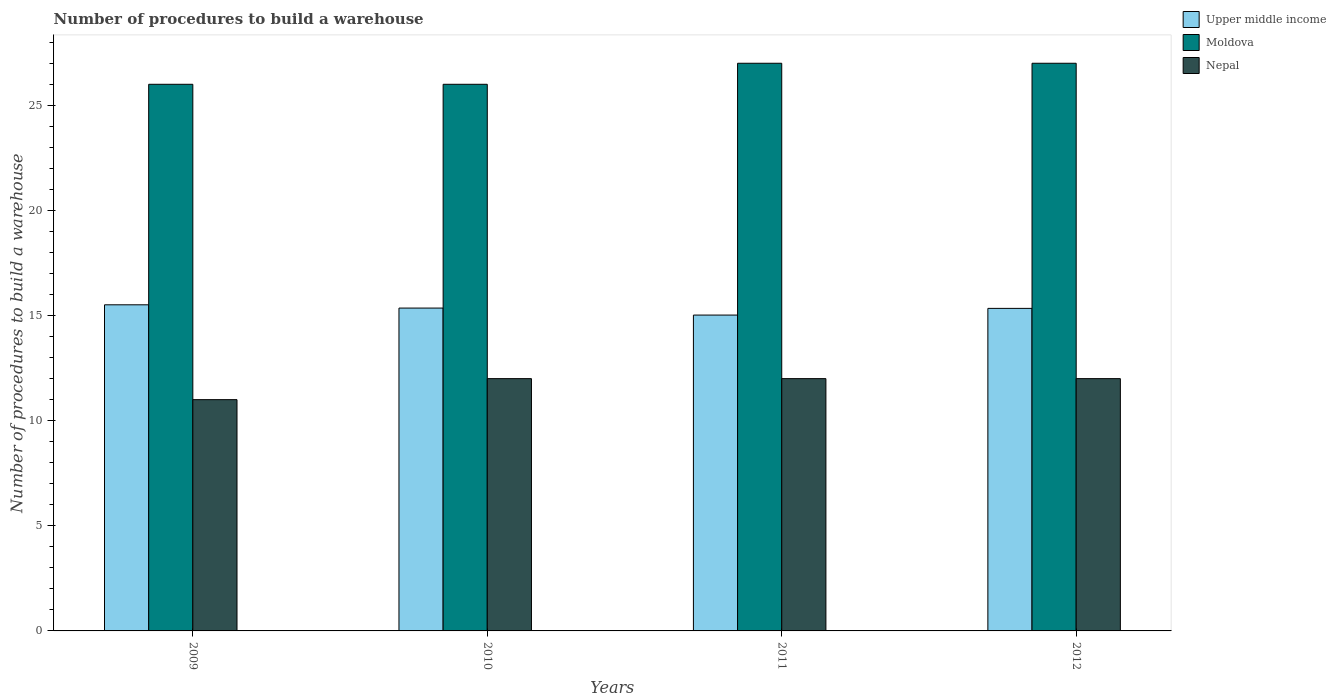How many groups of bars are there?
Your response must be concise. 4. Are the number of bars per tick equal to the number of legend labels?
Ensure brevity in your answer.  Yes. Are the number of bars on each tick of the X-axis equal?
Offer a terse response. Yes. What is the label of the 4th group of bars from the left?
Your answer should be compact. 2012. What is the number of procedures to build a warehouse in in Nepal in 2012?
Give a very brief answer. 12. Across all years, what is the maximum number of procedures to build a warehouse in in Moldova?
Your answer should be very brief. 27. Across all years, what is the minimum number of procedures to build a warehouse in in Moldova?
Keep it short and to the point. 26. In which year was the number of procedures to build a warehouse in in Upper middle income minimum?
Offer a terse response. 2011. What is the total number of procedures to build a warehouse in in Nepal in the graph?
Offer a terse response. 47. What is the difference between the number of procedures to build a warehouse in in Upper middle income in 2011 and that in 2012?
Give a very brief answer. -0.32. What is the difference between the number of procedures to build a warehouse in in Upper middle income in 2009 and the number of procedures to build a warehouse in in Moldova in 2012?
Offer a terse response. -11.49. What is the average number of procedures to build a warehouse in in Moldova per year?
Your answer should be compact. 26.5. In the year 2011, what is the difference between the number of procedures to build a warehouse in in Upper middle income and number of procedures to build a warehouse in in Moldova?
Make the answer very short. -11.98. What is the ratio of the number of procedures to build a warehouse in in Upper middle income in 2009 to that in 2011?
Your answer should be very brief. 1.03. Is the difference between the number of procedures to build a warehouse in in Upper middle income in 2009 and 2010 greater than the difference between the number of procedures to build a warehouse in in Moldova in 2009 and 2010?
Keep it short and to the point. Yes. What is the difference between the highest and the second highest number of procedures to build a warehouse in in Nepal?
Your answer should be very brief. 0. What is the difference between the highest and the lowest number of procedures to build a warehouse in in Nepal?
Your answer should be very brief. 1. In how many years, is the number of procedures to build a warehouse in in Moldova greater than the average number of procedures to build a warehouse in in Moldova taken over all years?
Ensure brevity in your answer.  2. What does the 2nd bar from the left in 2012 represents?
Your response must be concise. Moldova. What does the 1st bar from the right in 2012 represents?
Offer a terse response. Nepal. Are all the bars in the graph horizontal?
Offer a very short reply. No. How many years are there in the graph?
Your answer should be compact. 4. What is the difference between two consecutive major ticks on the Y-axis?
Offer a terse response. 5. How many legend labels are there?
Offer a terse response. 3. How are the legend labels stacked?
Provide a short and direct response. Vertical. What is the title of the graph?
Keep it short and to the point. Number of procedures to build a warehouse. Does "Monaco" appear as one of the legend labels in the graph?
Your answer should be compact. No. What is the label or title of the X-axis?
Offer a very short reply. Years. What is the label or title of the Y-axis?
Offer a very short reply. Number of procedures to build a warehouse. What is the Number of procedures to build a warehouse in Upper middle income in 2009?
Ensure brevity in your answer.  15.51. What is the Number of procedures to build a warehouse in Upper middle income in 2010?
Give a very brief answer. 15.36. What is the Number of procedures to build a warehouse of Moldova in 2010?
Your answer should be compact. 26. What is the Number of procedures to build a warehouse in Nepal in 2010?
Provide a succinct answer. 12. What is the Number of procedures to build a warehouse of Upper middle income in 2011?
Your response must be concise. 15.02. What is the Number of procedures to build a warehouse in Moldova in 2011?
Provide a succinct answer. 27. What is the Number of procedures to build a warehouse in Upper middle income in 2012?
Provide a succinct answer. 15.34. Across all years, what is the maximum Number of procedures to build a warehouse of Upper middle income?
Ensure brevity in your answer.  15.51. Across all years, what is the maximum Number of procedures to build a warehouse of Nepal?
Your answer should be compact. 12. Across all years, what is the minimum Number of procedures to build a warehouse in Upper middle income?
Make the answer very short. 15.02. Across all years, what is the minimum Number of procedures to build a warehouse in Nepal?
Provide a succinct answer. 11. What is the total Number of procedures to build a warehouse of Upper middle income in the graph?
Make the answer very short. 61.23. What is the total Number of procedures to build a warehouse in Moldova in the graph?
Keep it short and to the point. 106. What is the difference between the Number of procedures to build a warehouse of Upper middle income in 2009 and that in 2010?
Offer a very short reply. 0.16. What is the difference between the Number of procedures to build a warehouse in Upper middle income in 2009 and that in 2011?
Your answer should be compact. 0.49. What is the difference between the Number of procedures to build a warehouse of Upper middle income in 2009 and that in 2012?
Your response must be concise. 0.17. What is the difference between the Number of procedures to build a warehouse in Moldova in 2009 and that in 2012?
Your answer should be compact. -1. What is the difference between the Number of procedures to build a warehouse in Upper middle income in 2010 and that in 2011?
Give a very brief answer. 0.33. What is the difference between the Number of procedures to build a warehouse of Nepal in 2010 and that in 2011?
Your answer should be compact. 0. What is the difference between the Number of procedures to build a warehouse of Upper middle income in 2010 and that in 2012?
Give a very brief answer. 0.01. What is the difference between the Number of procedures to build a warehouse of Upper middle income in 2011 and that in 2012?
Offer a very short reply. -0.32. What is the difference between the Number of procedures to build a warehouse in Moldova in 2011 and that in 2012?
Your answer should be very brief. 0. What is the difference between the Number of procedures to build a warehouse in Upper middle income in 2009 and the Number of procedures to build a warehouse in Moldova in 2010?
Provide a succinct answer. -10.49. What is the difference between the Number of procedures to build a warehouse of Upper middle income in 2009 and the Number of procedures to build a warehouse of Nepal in 2010?
Ensure brevity in your answer.  3.51. What is the difference between the Number of procedures to build a warehouse in Upper middle income in 2009 and the Number of procedures to build a warehouse in Moldova in 2011?
Your answer should be very brief. -11.49. What is the difference between the Number of procedures to build a warehouse in Upper middle income in 2009 and the Number of procedures to build a warehouse in Nepal in 2011?
Provide a short and direct response. 3.51. What is the difference between the Number of procedures to build a warehouse in Upper middle income in 2009 and the Number of procedures to build a warehouse in Moldova in 2012?
Provide a short and direct response. -11.49. What is the difference between the Number of procedures to build a warehouse of Upper middle income in 2009 and the Number of procedures to build a warehouse of Nepal in 2012?
Your answer should be compact. 3.51. What is the difference between the Number of procedures to build a warehouse of Upper middle income in 2010 and the Number of procedures to build a warehouse of Moldova in 2011?
Provide a succinct answer. -11.64. What is the difference between the Number of procedures to build a warehouse of Upper middle income in 2010 and the Number of procedures to build a warehouse of Nepal in 2011?
Offer a terse response. 3.36. What is the difference between the Number of procedures to build a warehouse in Moldova in 2010 and the Number of procedures to build a warehouse in Nepal in 2011?
Give a very brief answer. 14. What is the difference between the Number of procedures to build a warehouse in Upper middle income in 2010 and the Number of procedures to build a warehouse in Moldova in 2012?
Offer a terse response. -11.64. What is the difference between the Number of procedures to build a warehouse in Upper middle income in 2010 and the Number of procedures to build a warehouse in Nepal in 2012?
Offer a terse response. 3.36. What is the difference between the Number of procedures to build a warehouse in Moldova in 2010 and the Number of procedures to build a warehouse in Nepal in 2012?
Make the answer very short. 14. What is the difference between the Number of procedures to build a warehouse of Upper middle income in 2011 and the Number of procedures to build a warehouse of Moldova in 2012?
Make the answer very short. -11.98. What is the difference between the Number of procedures to build a warehouse in Upper middle income in 2011 and the Number of procedures to build a warehouse in Nepal in 2012?
Ensure brevity in your answer.  3.02. What is the difference between the Number of procedures to build a warehouse in Moldova in 2011 and the Number of procedures to build a warehouse in Nepal in 2012?
Offer a very short reply. 15. What is the average Number of procedures to build a warehouse in Upper middle income per year?
Give a very brief answer. 15.31. What is the average Number of procedures to build a warehouse in Nepal per year?
Your response must be concise. 11.75. In the year 2009, what is the difference between the Number of procedures to build a warehouse in Upper middle income and Number of procedures to build a warehouse in Moldova?
Offer a terse response. -10.49. In the year 2009, what is the difference between the Number of procedures to build a warehouse of Upper middle income and Number of procedures to build a warehouse of Nepal?
Your response must be concise. 4.51. In the year 2009, what is the difference between the Number of procedures to build a warehouse of Moldova and Number of procedures to build a warehouse of Nepal?
Offer a very short reply. 15. In the year 2010, what is the difference between the Number of procedures to build a warehouse in Upper middle income and Number of procedures to build a warehouse in Moldova?
Offer a terse response. -10.64. In the year 2010, what is the difference between the Number of procedures to build a warehouse of Upper middle income and Number of procedures to build a warehouse of Nepal?
Ensure brevity in your answer.  3.36. In the year 2011, what is the difference between the Number of procedures to build a warehouse in Upper middle income and Number of procedures to build a warehouse in Moldova?
Provide a short and direct response. -11.98. In the year 2011, what is the difference between the Number of procedures to build a warehouse in Upper middle income and Number of procedures to build a warehouse in Nepal?
Provide a succinct answer. 3.02. In the year 2011, what is the difference between the Number of procedures to build a warehouse in Moldova and Number of procedures to build a warehouse in Nepal?
Provide a succinct answer. 15. In the year 2012, what is the difference between the Number of procedures to build a warehouse of Upper middle income and Number of procedures to build a warehouse of Moldova?
Ensure brevity in your answer.  -11.66. In the year 2012, what is the difference between the Number of procedures to build a warehouse of Upper middle income and Number of procedures to build a warehouse of Nepal?
Offer a very short reply. 3.34. In the year 2012, what is the difference between the Number of procedures to build a warehouse of Moldova and Number of procedures to build a warehouse of Nepal?
Provide a short and direct response. 15. What is the ratio of the Number of procedures to build a warehouse of Upper middle income in 2009 to that in 2011?
Your response must be concise. 1.03. What is the ratio of the Number of procedures to build a warehouse in Moldova in 2009 to that in 2011?
Provide a succinct answer. 0.96. What is the ratio of the Number of procedures to build a warehouse in Upper middle income in 2009 to that in 2012?
Keep it short and to the point. 1.01. What is the ratio of the Number of procedures to build a warehouse of Upper middle income in 2010 to that in 2011?
Provide a short and direct response. 1.02. What is the ratio of the Number of procedures to build a warehouse of Moldova in 2010 to that in 2011?
Keep it short and to the point. 0.96. What is the ratio of the Number of procedures to build a warehouse in Moldova in 2010 to that in 2012?
Offer a very short reply. 0.96. What is the ratio of the Number of procedures to build a warehouse in Upper middle income in 2011 to that in 2012?
Offer a terse response. 0.98. What is the ratio of the Number of procedures to build a warehouse in Moldova in 2011 to that in 2012?
Give a very brief answer. 1. What is the difference between the highest and the second highest Number of procedures to build a warehouse of Upper middle income?
Provide a succinct answer. 0.16. What is the difference between the highest and the second highest Number of procedures to build a warehouse in Nepal?
Provide a short and direct response. 0. What is the difference between the highest and the lowest Number of procedures to build a warehouse in Upper middle income?
Your answer should be compact. 0.49. What is the difference between the highest and the lowest Number of procedures to build a warehouse of Nepal?
Ensure brevity in your answer.  1. 